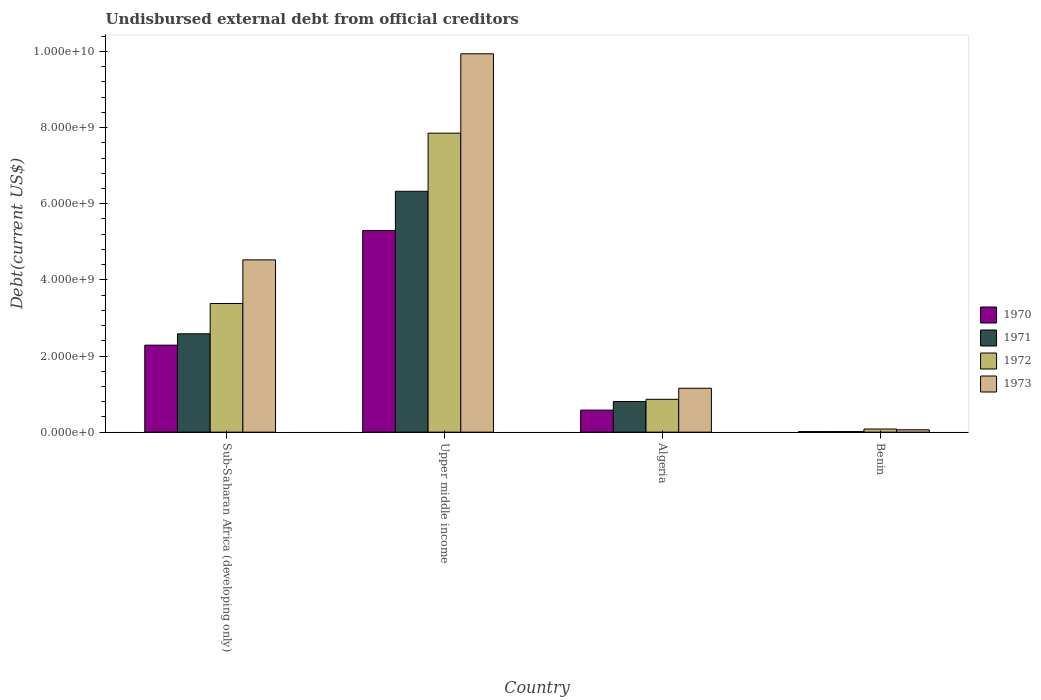How many different coloured bars are there?
Make the answer very short. 4. Are the number of bars per tick equal to the number of legend labels?
Make the answer very short. Yes. Are the number of bars on each tick of the X-axis equal?
Your response must be concise. Yes. How many bars are there on the 1st tick from the left?
Offer a terse response. 4. What is the label of the 3rd group of bars from the left?
Keep it short and to the point. Algeria. What is the total debt in 1973 in Algeria?
Keep it short and to the point. 1.15e+09. Across all countries, what is the maximum total debt in 1972?
Your response must be concise. 7.85e+09. Across all countries, what is the minimum total debt in 1970?
Give a very brief answer. 1.53e+07. In which country was the total debt in 1972 maximum?
Provide a succinct answer. Upper middle income. In which country was the total debt in 1972 minimum?
Provide a succinct answer. Benin. What is the total total debt in 1973 in the graph?
Offer a very short reply. 1.57e+1. What is the difference between the total debt in 1973 in Benin and that in Sub-Saharan Africa (developing only)?
Make the answer very short. -4.46e+09. What is the difference between the total debt in 1973 in Benin and the total debt in 1972 in Sub-Saharan Africa (developing only)?
Offer a terse response. -3.32e+09. What is the average total debt in 1972 per country?
Offer a terse response. 3.04e+09. What is the difference between the total debt of/in 1972 and total debt of/in 1973 in Sub-Saharan Africa (developing only)?
Offer a very short reply. -1.15e+09. In how many countries, is the total debt in 1971 greater than 8000000000 US$?
Your answer should be very brief. 0. What is the ratio of the total debt in 1973 in Algeria to that in Sub-Saharan Africa (developing only)?
Offer a terse response. 0.25. What is the difference between the highest and the second highest total debt in 1971?
Make the answer very short. 5.52e+09. What is the difference between the highest and the lowest total debt in 1971?
Give a very brief answer. 6.31e+09. Is the sum of the total debt in 1972 in Algeria and Benin greater than the maximum total debt in 1970 across all countries?
Your answer should be compact. No. What does the 2nd bar from the right in Algeria represents?
Provide a short and direct response. 1972. How many bars are there?
Provide a short and direct response. 16. How many countries are there in the graph?
Keep it short and to the point. 4. Does the graph contain grids?
Give a very brief answer. No. How many legend labels are there?
Offer a terse response. 4. What is the title of the graph?
Give a very brief answer. Undisbursed external debt from official creditors. What is the label or title of the Y-axis?
Offer a terse response. Debt(current US$). What is the Debt(current US$) in 1970 in Sub-Saharan Africa (developing only)?
Provide a short and direct response. 2.28e+09. What is the Debt(current US$) in 1971 in Sub-Saharan Africa (developing only)?
Offer a very short reply. 2.58e+09. What is the Debt(current US$) in 1972 in Sub-Saharan Africa (developing only)?
Provide a short and direct response. 3.38e+09. What is the Debt(current US$) in 1973 in Sub-Saharan Africa (developing only)?
Give a very brief answer. 4.53e+09. What is the Debt(current US$) in 1970 in Upper middle income?
Give a very brief answer. 5.30e+09. What is the Debt(current US$) of 1971 in Upper middle income?
Your answer should be very brief. 6.33e+09. What is the Debt(current US$) of 1972 in Upper middle income?
Give a very brief answer. 7.85e+09. What is the Debt(current US$) in 1973 in Upper middle income?
Your answer should be compact. 9.94e+09. What is the Debt(current US$) in 1970 in Algeria?
Ensure brevity in your answer.  5.79e+08. What is the Debt(current US$) in 1971 in Algeria?
Provide a succinct answer. 8.05e+08. What is the Debt(current US$) in 1972 in Algeria?
Make the answer very short. 8.62e+08. What is the Debt(current US$) in 1973 in Algeria?
Your response must be concise. 1.15e+09. What is the Debt(current US$) in 1970 in Benin?
Give a very brief answer. 1.53e+07. What is the Debt(current US$) of 1971 in Benin?
Provide a short and direct response. 1.57e+07. What is the Debt(current US$) in 1972 in Benin?
Keep it short and to the point. 8.25e+07. What is the Debt(current US$) in 1973 in Benin?
Ensure brevity in your answer.  6.20e+07. Across all countries, what is the maximum Debt(current US$) of 1970?
Provide a succinct answer. 5.30e+09. Across all countries, what is the maximum Debt(current US$) of 1971?
Offer a very short reply. 6.33e+09. Across all countries, what is the maximum Debt(current US$) of 1972?
Your response must be concise. 7.85e+09. Across all countries, what is the maximum Debt(current US$) in 1973?
Offer a terse response. 9.94e+09. Across all countries, what is the minimum Debt(current US$) of 1970?
Keep it short and to the point. 1.53e+07. Across all countries, what is the minimum Debt(current US$) in 1971?
Your answer should be very brief. 1.57e+07. Across all countries, what is the minimum Debt(current US$) in 1972?
Your response must be concise. 8.25e+07. Across all countries, what is the minimum Debt(current US$) of 1973?
Your answer should be compact. 6.20e+07. What is the total Debt(current US$) of 1970 in the graph?
Keep it short and to the point. 8.17e+09. What is the total Debt(current US$) in 1971 in the graph?
Your response must be concise. 9.73e+09. What is the total Debt(current US$) in 1972 in the graph?
Offer a very short reply. 1.22e+1. What is the total Debt(current US$) in 1973 in the graph?
Your response must be concise. 1.57e+1. What is the difference between the Debt(current US$) in 1970 in Sub-Saharan Africa (developing only) and that in Upper middle income?
Give a very brief answer. -3.01e+09. What is the difference between the Debt(current US$) of 1971 in Sub-Saharan Africa (developing only) and that in Upper middle income?
Give a very brief answer. -3.74e+09. What is the difference between the Debt(current US$) in 1972 in Sub-Saharan Africa (developing only) and that in Upper middle income?
Provide a succinct answer. -4.47e+09. What is the difference between the Debt(current US$) in 1973 in Sub-Saharan Africa (developing only) and that in Upper middle income?
Your response must be concise. -5.41e+09. What is the difference between the Debt(current US$) of 1970 in Sub-Saharan Africa (developing only) and that in Algeria?
Offer a terse response. 1.71e+09. What is the difference between the Debt(current US$) in 1971 in Sub-Saharan Africa (developing only) and that in Algeria?
Keep it short and to the point. 1.78e+09. What is the difference between the Debt(current US$) of 1972 in Sub-Saharan Africa (developing only) and that in Algeria?
Give a very brief answer. 2.52e+09. What is the difference between the Debt(current US$) in 1973 in Sub-Saharan Africa (developing only) and that in Algeria?
Offer a terse response. 3.37e+09. What is the difference between the Debt(current US$) in 1970 in Sub-Saharan Africa (developing only) and that in Benin?
Your answer should be very brief. 2.27e+09. What is the difference between the Debt(current US$) of 1971 in Sub-Saharan Africa (developing only) and that in Benin?
Make the answer very short. 2.57e+09. What is the difference between the Debt(current US$) of 1972 in Sub-Saharan Africa (developing only) and that in Benin?
Your response must be concise. 3.30e+09. What is the difference between the Debt(current US$) of 1973 in Sub-Saharan Africa (developing only) and that in Benin?
Give a very brief answer. 4.46e+09. What is the difference between the Debt(current US$) in 1970 in Upper middle income and that in Algeria?
Give a very brief answer. 4.72e+09. What is the difference between the Debt(current US$) in 1971 in Upper middle income and that in Algeria?
Ensure brevity in your answer.  5.52e+09. What is the difference between the Debt(current US$) of 1972 in Upper middle income and that in Algeria?
Provide a short and direct response. 6.99e+09. What is the difference between the Debt(current US$) in 1973 in Upper middle income and that in Algeria?
Your answer should be very brief. 8.79e+09. What is the difference between the Debt(current US$) in 1970 in Upper middle income and that in Benin?
Your answer should be very brief. 5.28e+09. What is the difference between the Debt(current US$) of 1971 in Upper middle income and that in Benin?
Your answer should be compact. 6.31e+09. What is the difference between the Debt(current US$) of 1972 in Upper middle income and that in Benin?
Your response must be concise. 7.77e+09. What is the difference between the Debt(current US$) of 1973 in Upper middle income and that in Benin?
Your response must be concise. 9.88e+09. What is the difference between the Debt(current US$) in 1970 in Algeria and that in Benin?
Keep it short and to the point. 5.64e+08. What is the difference between the Debt(current US$) of 1971 in Algeria and that in Benin?
Your response must be concise. 7.89e+08. What is the difference between the Debt(current US$) of 1972 in Algeria and that in Benin?
Offer a terse response. 7.80e+08. What is the difference between the Debt(current US$) in 1973 in Algeria and that in Benin?
Ensure brevity in your answer.  1.09e+09. What is the difference between the Debt(current US$) in 1970 in Sub-Saharan Africa (developing only) and the Debt(current US$) in 1971 in Upper middle income?
Your response must be concise. -4.04e+09. What is the difference between the Debt(current US$) in 1970 in Sub-Saharan Africa (developing only) and the Debt(current US$) in 1972 in Upper middle income?
Keep it short and to the point. -5.57e+09. What is the difference between the Debt(current US$) in 1970 in Sub-Saharan Africa (developing only) and the Debt(current US$) in 1973 in Upper middle income?
Your answer should be compact. -7.65e+09. What is the difference between the Debt(current US$) of 1971 in Sub-Saharan Africa (developing only) and the Debt(current US$) of 1972 in Upper middle income?
Ensure brevity in your answer.  -5.27e+09. What is the difference between the Debt(current US$) in 1971 in Sub-Saharan Africa (developing only) and the Debt(current US$) in 1973 in Upper middle income?
Give a very brief answer. -7.36e+09. What is the difference between the Debt(current US$) in 1972 in Sub-Saharan Africa (developing only) and the Debt(current US$) in 1973 in Upper middle income?
Make the answer very short. -6.56e+09. What is the difference between the Debt(current US$) of 1970 in Sub-Saharan Africa (developing only) and the Debt(current US$) of 1971 in Algeria?
Provide a short and direct response. 1.48e+09. What is the difference between the Debt(current US$) in 1970 in Sub-Saharan Africa (developing only) and the Debt(current US$) in 1972 in Algeria?
Give a very brief answer. 1.42e+09. What is the difference between the Debt(current US$) of 1970 in Sub-Saharan Africa (developing only) and the Debt(current US$) of 1973 in Algeria?
Your answer should be very brief. 1.13e+09. What is the difference between the Debt(current US$) in 1971 in Sub-Saharan Africa (developing only) and the Debt(current US$) in 1972 in Algeria?
Give a very brief answer. 1.72e+09. What is the difference between the Debt(current US$) of 1971 in Sub-Saharan Africa (developing only) and the Debt(current US$) of 1973 in Algeria?
Keep it short and to the point. 1.43e+09. What is the difference between the Debt(current US$) in 1972 in Sub-Saharan Africa (developing only) and the Debt(current US$) in 1973 in Algeria?
Give a very brief answer. 2.23e+09. What is the difference between the Debt(current US$) in 1970 in Sub-Saharan Africa (developing only) and the Debt(current US$) in 1971 in Benin?
Ensure brevity in your answer.  2.27e+09. What is the difference between the Debt(current US$) in 1970 in Sub-Saharan Africa (developing only) and the Debt(current US$) in 1972 in Benin?
Ensure brevity in your answer.  2.20e+09. What is the difference between the Debt(current US$) of 1970 in Sub-Saharan Africa (developing only) and the Debt(current US$) of 1973 in Benin?
Provide a short and direct response. 2.22e+09. What is the difference between the Debt(current US$) in 1971 in Sub-Saharan Africa (developing only) and the Debt(current US$) in 1972 in Benin?
Your answer should be compact. 2.50e+09. What is the difference between the Debt(current US$) of 1971 in Sub-Saharan Africa (developing only) and the Debt(current US$) of 1973 in Benin?
Keep it short and to the point. 2.52e+09. What is the difference between the Debt(current US$) in 1972 in Sub-Saharan Africa (developing only) and the Debt(current US$) in 1973 in Benin?
Keep it short and to the point. 3.32e+09. What is the difference between the Debt(current US$) in 1970 in Upper middle income and the Debt(current US$) in 1971 in Algeria?
Your answer should be compact. 4.49e+09. What is the difference between the Debt(current US$) in 1970 in Upper middle income and the Debt(current US$) in 1972 in Algeria?
Keep it short and to the point. 4.43e+09. What is the difference between the Debt(current US$) in 1970 in Upper middle income and the Debt(current US$) in 1973 in Algeria?
Your answer should be very brief. 4.14e+09. What is the difference between the Debt(current US$) of 1971 in Upper middle income and the Debt(current US$) of 1972 in Algeria?
Your answer should be very brief. 5.46e+09. What is the difference between the Debt(current US$) of 1971 in Upper middle income and the Debt(current US$) of 1973 in Algeria?
Provide a short and direct response. 5.17e+09. What is the difference between the Debt(current US$) of 1972 in Upper middle income and the Debt(current US$) of 1973 in Algeria?
Keep it short and to the point. 6.70e+09. What is the difference between the Debt(current US$) in 1970 in Upper middle income and the Debt(current US$) in 1971 in Benin?
Provide a short and direct response. 5.28e+09. What is the difference between the Debt(current US$) of 1970 in Upper middle income and the Debt(current US$) of 1972 in Benin?
Offer a terse response. 5.21e+09. What is the difference between the Debt(current US$) of 1970 in Upper middle income and the Debt(current US$) of 1973 in Benin?
Offer a terse response. 5.23e+09. What is the difference between the Debt(current US$) of 1971 in Upper middle income and the Debt(current US$) of 1972 in Benin?
Provide a succinct answer. 6.24e+09. What is the difference between the Debt(current US$) of 1971 in Upper middle income and the Debt(current US$) of 1973 in Benin?
Give a very brief answer. 6.26e+09. What is the difference between the Debt(current US$) of 1972 in Upper middle income and the Debt(current US$) of 1973 in Benin?
Offer a very short reply. 7.79e+09. What is the difference between the Debt(current US$) of 1970 in Algeria and the Debt(current US$) of 1971 in Benin?
Keep it short and to the point. 5.63e+08. What is the difference between the Debt(current US$) in 1970 in Algeria and the Debt(current US$) in 1972 in Benin?
Make the answer very short. 4.96e+08. What is the difference between the Debt(current US$) in 1970 in Algeria and the Debt(current US$) in 1973 in Benin?
Offer a very short reply. 5.17e+08. What is the difference between the Debt(current US$) in 1971 in Algeria and the Debt(current US$) in 1972 in Benin?
Give a very brief answer. 7.22e+08. What is the difference between the Debt(current US$) in 1971 in Algeria and the Debt(current US$) in 1973 in Benin?
Provide a succinct answer. 7.43e+08. What is the difference between the Debt(current US$) of 1972 in Algeria and the Debt(current US$) of 1973 in Benin?
Give a very brief answer. 8.00e+08. What is the average Debt(current US$) of 1970 per country?
Provide a short and direct response. 2.04e+09. What is the average Debt(current US$) in 1971 per country?
Keep it short and to the point. 2.43e+09. What is the average Debt(current US$) of 1972 per country?
Give a very brief answer. 3.04e+09. What is the average Debt(current US$) of 1973 per country?
Your answer should be very brief. 3.92e+09. What is the difference between the Debt(current US$) of 1970 and Debt(current US$) of 1971 in Sub-Saharan Africa (developing only)?
Keep it short and to the point. -2.99e+08. What is the difference between the Debt(current US$) of 1970 and Debt(current US$) of 1972 in Sub-Saharan Africa (developing only)?
Offer a very short reply. -1.09e+09. What is the difference between the Debt(current US$) of 1970 and Debt(current US$) of 1973 in Sub-Saharan Africa (developing only)?
Offer a terse response. -2.24e+09. What is the difference between the Debt(current US$) in 1971 and Debt(current US$) in 1972 in Sub-Saharan Africa (developing only)?
Your response must be concise. -7.96e+08. What is the difference between the Debt(current US$) in 1971 and Debt(current US$) in 1973 in Sub-Saharan Africa (developing only)?
Offer a very short reply. -1.94e+09. What is the difference between the Debt(current US$) in 1972 and Debt(current US$) in 1973 in Sub-Saharan Africa (developing only)?
Provide a short and direct response. -1.15e+09. What is the difference between the Debt(current US$) in 1970 and Debt(current US$) in 1971 in Upper middle income?
Your response must be concise. -1.03e+09. What is the difference between the Debt(current US$) in 1970 and Debt(current US$) in 1972 in Upper middle income?
Offer a terse response. -2.56e+09. What is the difference between the Debt(current US$) of 1970 and Debt(current US$) of 1973 in Upper middle income?
Offer a very short reply. -4.64e+09. What is the difference between the Debt(current US$) of 1971 and Debt(current US$) of 1972 in Upper middle income?
Give a very brief answer. -1.53e+09. What is the difference between the Debt(current US$) of 1971 and Debt(current US$) of 1973 in Upper middle income?
Give a very brief answer. -3.61e+09. What is the difference between the Debt(current US$) of 1972 and Debt(current US$) of 1973 in Upper middle income?
Ensure brevity in your answer.  -2.08e+09. What is the difference between the Debt(current US$) of 1970 and Debt(current US$) of 1971 in Algeria?
Your answer should be compact. -2.26e+08. What is the difference between the Debt(current US$) in 1970 and Debt(current US$) in 1972 in Algeria?
Keep it short and to the point. -2.83e+08. What is the difference between the Debt(current US$) in 1970 and Debt(current US$) in 1973 in Algeria?
Provide a short and direct response. -5.75e+08. What is the difference between the Debt(current US$) in 1971 and Debt(current US$) in 1972 in Algeria?
Ensure brevity in your answer.  -5.74e+07. What is the difference between the Debt(current US$) of 1971 and Debt(current US$) of 1973 in Algeria?
Your answer should be compact. -3.49e+08. What is the difference between the Debt(current US$) of 1972 and Debt(current US$) of 1973 in Algeria?
Your answer should be very brief. -2.91e+08. What is the difference between the Debt(current US$) of 1970 and Debt(current US$) of 1971 in Benin?
Make the answer very short. -3.83e+05. What is the difference between the Debt(current US$) in 1970 and Debt(current US$) in 1972 in Benin?
Offer a terse response. -6.72e+07. What is the difference between the Debt(current US$) in 1970 and Debt(current US$) in 1973 in Benin?
Your response must be concise. -4.67e+07. What is the difference between the Debt(current US$) in 1971 and Debt(current US$) in 1972 in Benin?
Ensure brevity in your answer.  -6.68e+07. What is the difference between the Debt(current US$) of 1971 and Debt(current US$) of 1973 in Benin?
Give a very brief answer. -4.63e+07. What is the difference between the Debt(current US$) of 1972 and Debt(current US$) of 1973 in Benin?
Your answer should be very brief. 2.05e+07. What is the ratio of the Debt(current US$) in 1970 in Sub-Saharan Africa (developing only) to that in Upper middle income?
Make the answer very short. 0.43. What is the ratio of the Debt(current US$) of 1971 in Sub-Saharan Africa (developing only) to that in Upper middle income?
Keep it short and to the point. 0.41. What is the ratio of the Debt(current US$) of 1972 in Sub-Saharan Africa (developing only) to that in Upper middle income?
Make the answer very short. 0.43. What is the ratio of the Debt(current US$) of 1973 in Sub-Saharan Africa (developing only) to that in Upper middle income?
Offer a terse response. 0.46. What is the ratio of the Debt(current US$) of 1970 in Sub-Saharan Africa (developing only) to that in Algeria?
Give a very brief answer. 3.95. What is the ratio of the Debt(current US$) of 1971 in Sub-Saharan Africa (developing only) to that in Algeria?
Provide a short and direct response. 3.21. What is the ratio of the Debt(current US$) of 1972 in Sub-Saharan Africa (developing only) to that in Algeria?
Make the answer very short. 3.92. What is the ratio of the Debt(current US$) of 1973 in Sub-Saharan Africa (developing only) to that in Algeria?
Ensure brevity in your answer.  3.92. What is the ratio of the Debt(current US$) in 1970 in Sub-Saharan Africa (developing only) to that in Benin?
Provide a succinct answer. 149.45. What is the ratio of the Debt(current US$) of 1971 in Sub-Saharan Africa (developing only) to that in Benin?
Provide a short and direct response. 164.88. What is the ratio of the Debt(current US$) of 1972 in Sub-Saharan Africa (developing only) to that in Benin?
Keep it short and to the point. 40.97. What is the ratio of the Debt(current US$) of 1973 in Sub-Saharan Africa (developing only) to that in Benin?
Provide a short and direct response. 73.02. What is the ratio of the Debt(current US$) of 1970 in Upper middle income to that in Algeria?
Provide a succinct answer. 9.15. What is the ratio of the Debt(current US$) in 1971 in Upper middle income to that in Algeria?
Your response must be concise. 7.86. What is the ratio of the Debt(current US$) of 1972 in Upper middle income to that in Algeria?
Give a very brief answer. 9.11. What is the ratio of the Debt(current US$) of 1973 in Upper middle income to that in Algeria?
Offer a terse response. 8.62. What is the ratio of the Debt(current US$) in 1970 in Upper middle income to that in Benin?
Ensure brevity in your answer.  346.37. What is the ratio of the Debt(current US$) of 1971 in Upper middle income to that in Benin?
Provide a succinct answer. 403.72. What is the ratio of the Debt(current US$) in 1972 in Upper middle income to that in Benin?
Keep it short and to the point. 95.21. What is the ratio of the Debt(current US$) in 1973 in Upper middle income to that in Benin?
Make the answer very short. 160.36. What is the ratio of the Debt(current US$) of 1970 in Algeria to that in Benin?
Make the answer very short. 37.87. What is the ratio of the Debt(current US$) of 1971 in Algeria to that in Benin?
Your answer should be very brief. 51.36. What is the ratio of the Debt(current US$) of 1972 in Algeria to that in Benin?
Provide a short and direct response. 10.45. What is the ratio of the Debt(current US$) of 1973 in Algeria to that in Benin?
Offer a very short reply. 18.61. What is the difference between the highest and the second highest Debt(current US$) of 1970?
Offer a terse response. 3.01e+09. What is the difference between the highest and the second highest Debt(current US$) of 1971?
Offer a terse response. 3.74e+09. What is the difference between the highest and the second highest Debt(current US$) in 1972?
Provide a short and direct response. 4.47e+09. What is the difference between the highest and the second highest Debt(current US$) in 1973?
Provide a succinct answer. 5.41e+09. What is the difference between the highest and the lowest Debt(current US$) in 1970?
Give a very brief answer. 5.28e+09. What is the difference between the highest and the lowest Debt(current US$) of 1971?
Keep it short and to the point. 6.31e+09. What is the difference between the highest and the lowest Debt(current US$) of 1972?
Ensure brevity in your answer.  7.77e+09. What is the difference between the highest and the lowest Debt(current US$) in 1973?
Ensure brevity in your answer.  9.88e+09. 